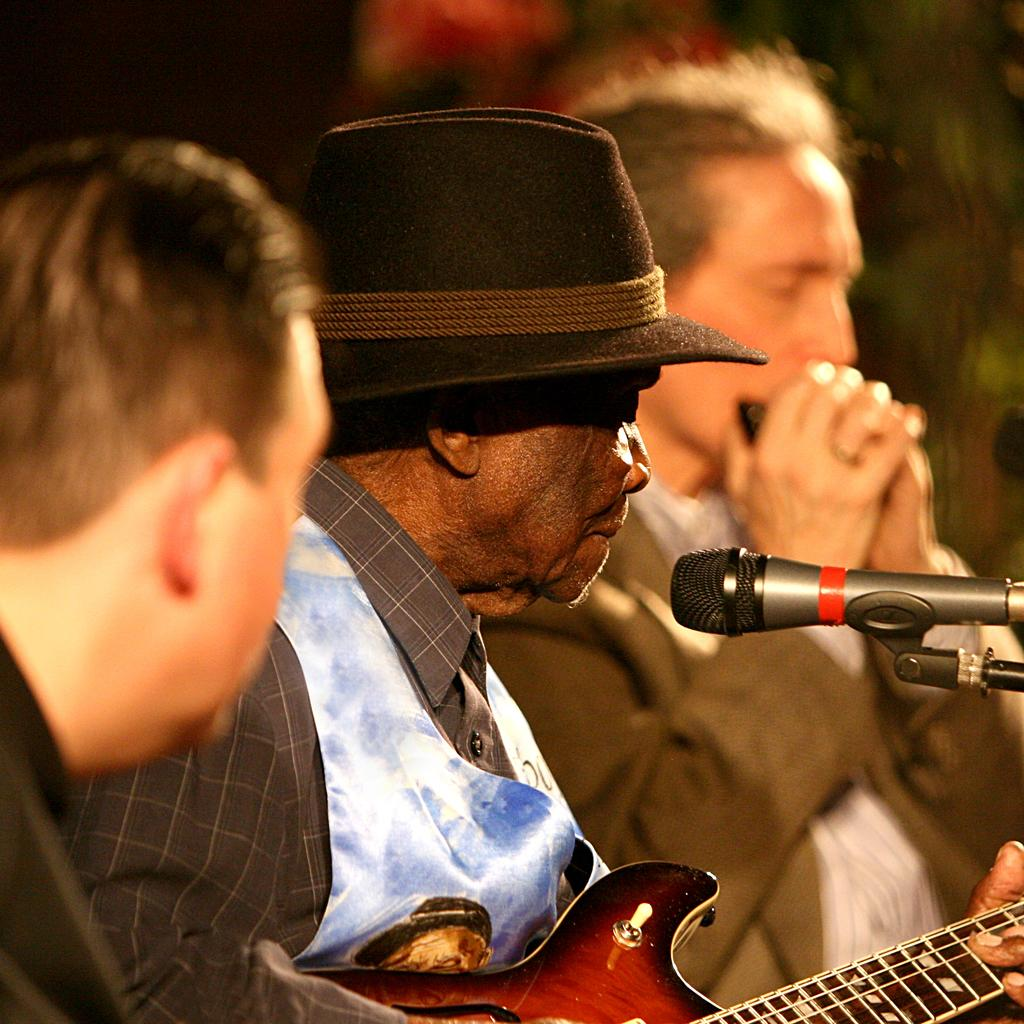What is the main activity being performed by the man in the image? The man is playing a guitar in the image. Are there any other musicians in the image? Yes, there is another person playing a musical instrument in the image. Can you describe the position of the third person in the image? There is another person to the left in the image. What type of angle is used to capture the details of the guitar in the image? The facts provided do not mention the angle or perspective used to capture the image, so it cannot be determined from the information given. 